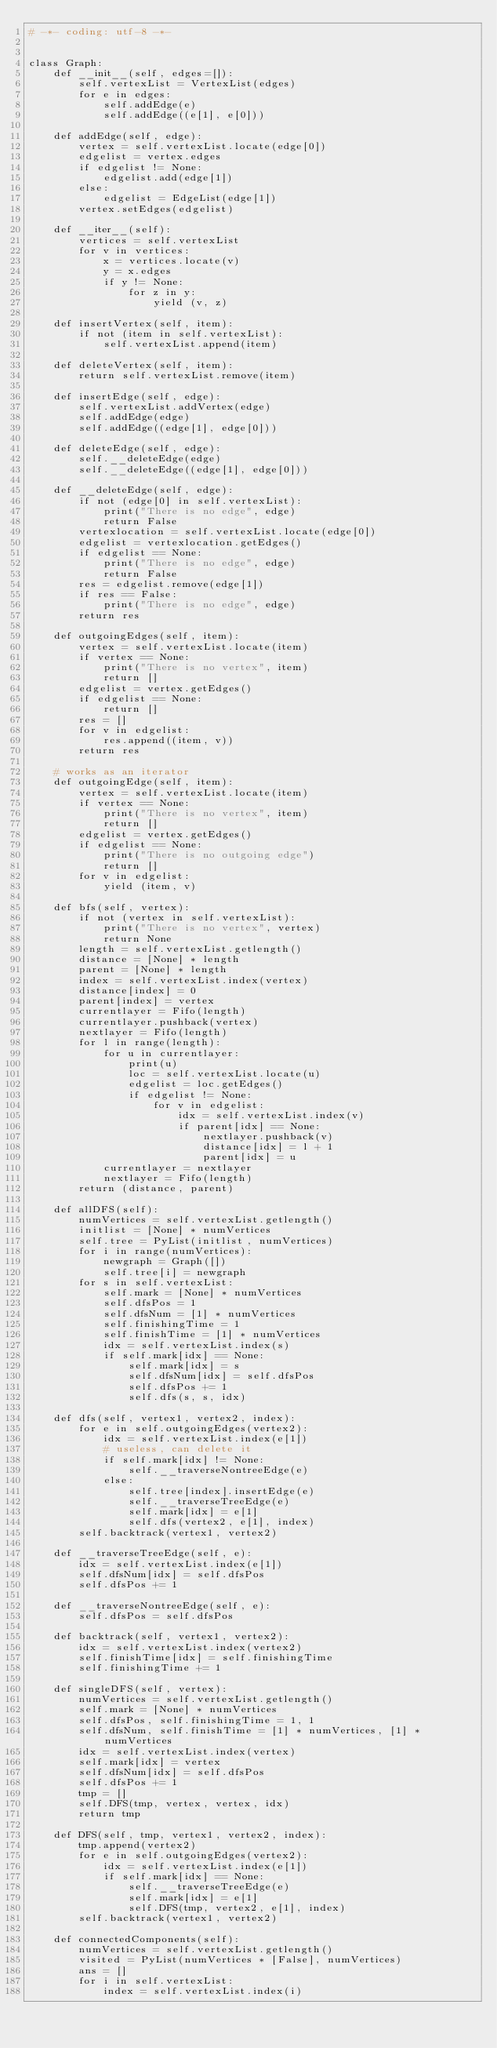<code> <loc_0><loc_0><loc_500><loc_500><_Python_># -*- coding: utf-8 -*-


class Graph:
    def __init__(self, edges=[]):
        self.vertexList = VertexList(edges)
        for e in edges:
            self.addEdge(e)
            self.addEdge((e[1], e[0]))

    def addEdge(self, edge):
        vertex = self.vertexList.locate(edge[0])
        edgelist = vertex.edges
        if edgelist != None:
            edgelist.add(edge[1])
        else:
            edgelist = EdgeList(edge[1])
        vertex.setEdges(edgelist)

    def __iter__(self):
        vertices = self.vertexList
        for v in vertices:
            x = vertices.locate(v)
            y = x.edges
            if y != None:
                for z in y:
                    yield (v, z)

    def insertVertex(self, item):
        if not (item in self.vertexList):
            self.vertexList.append(item)

    def deleteVertex(self, item):
        return self.vertexList.remove(item)

    def insertEdge(self, edge):
        self.vertexList.addVertex(edge)
        self.addEdge(edge)
        self.addEdge((edge[1], edge[0]))

    def deleteEdge(self, edge):
        self.__deleteEdge(edge)
        self.__deleteEdge((edge[1], edge[0]))

    def __deleteEdge(self, edge):
        if not (edge[0] in self.vertexList):
            print("There is no edge", edge)
            return False
        vertexlocation = self.vertexList.locate(edge[0])
        edgelist = vertexlocation.getEdges()
        if edgelist == None:
            print("There is no edge", edge)
            return False
        res = edgelist.remove(edge[1])
        if res == False:
            print("There is no edge", edge)
        return res

    def outgoingEdges(self, item):
        vertex = self.vertexList.locate(item)
        if vertex == None:
            print("There is no vertex", item)
            return []
        edgelist = vertex.getEdges()
        if edgelist == None:
            return []
        res = []
        for v in edgelist:
            res.append((item, v))
        return res

    # works as an iterator
    def outgoingEdge(self, item):
        vertex = self.vertexList.locate(item)
        if vertex == None:
            print("There is no vertex", item)
            return []
        edgelist = vertex.getEdges()
        if edgelist == None:
            print("There is no outgoing edge")
            return []
        for v in edgelist:
            yield (item, v)

    def bfs(self, vertex):
        if not (vertex in self.vertexList):
            print("There is no vertex", vertex)
            return None
        length = self.vertexList.getlength()
        distance = [None] * length
        parent = [None] * length
        index = self.vertexList.index(vertex)
        distance[index] = 0
        parent[index] = vertex
        currentlayer = Fifo(length)
        currentlayer.pushback(vertex)
        nextlayer = Fifo(length)
        for l in range(length):
            for u in currentlayer:
                print(u)
                loc = self.vertexList.locate(u)
                edgelist = loc.getEdges()
                if edgelist != None:
                    for v in edgelist:
                        idx = self.vertexList.index(v)
                        if parent[idx] == None:
                            nextlayer.pushback(v)
                            distance[idx] = l + 1
                            parent[idx] = u
            currentlayer = nextlayer
            nextlayer = Fifo(length)
        return (distance, parent)

    def allDFS(self):
        numVertices = self.vertexList.getlength()
        initlist = [None] * numVertices
        self.tree = PyList(initlist, numVertices)
        for i in range(numVertices):
            newgraph = Graph([])
            self.tree[i] = newgraph
        for s in self.vertexList:
            self.mark = [None] * numVertices
            self.dfsPos = 1   
            self.dfsNum = [1] * numVertices
            self.finishingTime = 1
            self.finishTime = [1] * numVertices
            idx = self.vertexList.index(s)
            if self.mark[idx] == None:
                self.mark[idx] = s
                self.dfsNum[idx] = self.dfsPos
                self.dfsPos += 1
                self.dfs(s, s, idx)

    def dfs(self, vertex1, vertex2, index):
        for e in self.outgoingEdges(vertex2):
            idx = self.vertexList.index(e[1])
            # useless, can delete it
            if self.mark[idx] != None:
                self.__traverseNontreeEdge(e)
            else:
                self.tree[index].insertEdge(e)
                self.__traverseTreeEdge(e)
                self.mark[idx] = e[1]
                self.dfs(vertex2, e[1], index)
        self.backtrack(vertex1, vertex2)

    def __traverseTreeEdge(self, e):
        idx = self.vertexList.index(e[1])
        self.dfsNum[idx] = self.dfsPos
        self.dfsPos += 1

    def __traverseNontreeEdge(self, e):
        self.dfsPos = self.dfsPos

    def backtrack(self, vertex1, vertex2):
        idx = self.vertexList.index(vertex2)
        self.finishTime[idx] = self.finishingTime
        self.finishingTime += 1
    
    def singleDFS(self, vertex):
        numVertices = self.vertexList.getlength()
        self.mark = [None] * numVertices
        self.dfsPos, self.finishingTime = 1, 1   
        self.dfsNum, self.finishTime = [1] * numVertices, [1] * numVertices
        idx = self.vertexList.index(vertex)
        self.mark[idx] = vertex
        self.dfsNum[idx] = self.dfsPos
        self.dfsPos += 1
        tmp = []
        self.DFS(tmp, vertex, vertex, idx)
        return tmp
            
    def DFS(self, tmp, vertex1, vertex2, index):
        tmp.append(vertex2)
        for e in self.outgoingEdges(vertex2):
            idx = self.vertexList.index(e[1])
            if self.mark[idx] == None:
                self.__traverseTreeEdge(e)
                self.mark[idx] = e[1]
                self.DFS(tmp, vertex2, e[1], index)
        self.backtrack(vertex1, vertex2)

    def connectedComponents(self):
        numVertices = self.vertexList.getlength()
        visited = PyList(numVertices * [False], numVertices)
        ans = []
        for i in self.vertexList:
            index = self.vertexList.index(i)</code> 